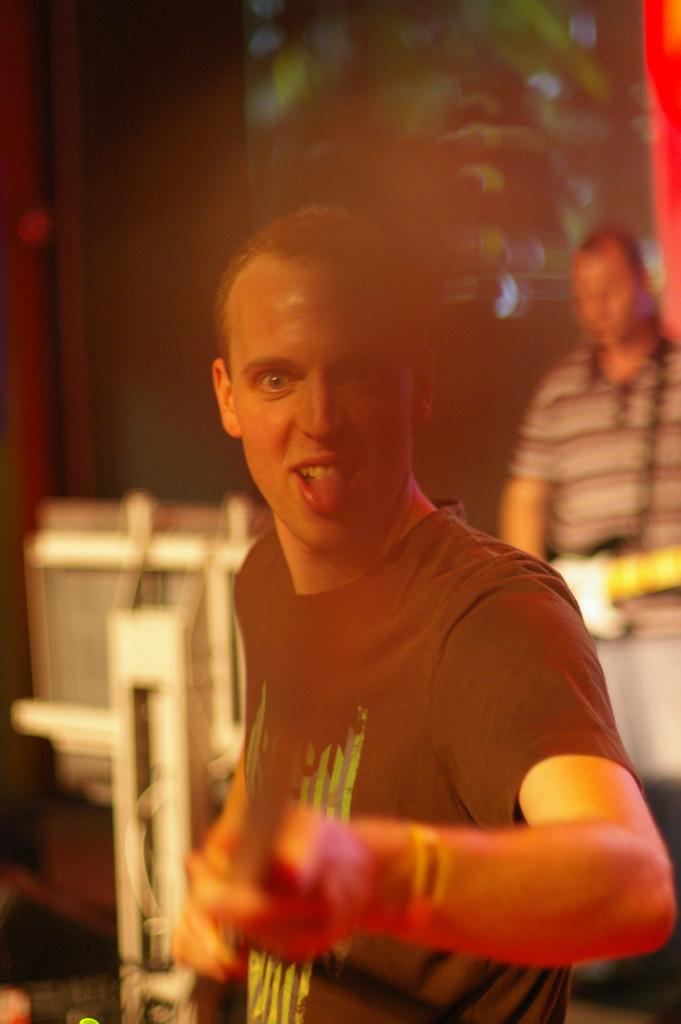What is the main subject of the image? There is a person standing in the image. Can you describe the person's expression or gesture? The person has a gesture on their face. What is the person doing in the image? The person is posing for the camera. Are there any other people in the image? Yes, there is another person standing behind the first person. How many babies are crawling on the floor in the image? There are no babies present in the image. What type of mist can be seen surrounding the people in the image? There is no mist present in the image. 